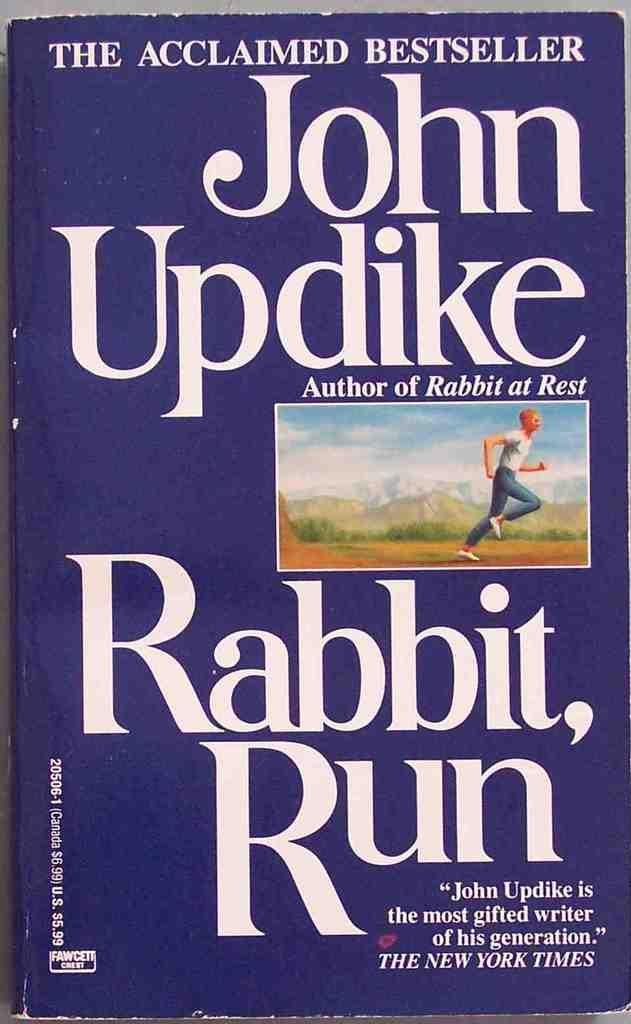<image>
Offer a succinct explanation of the picture presented. A book by John Updike called Rabbit Run. 